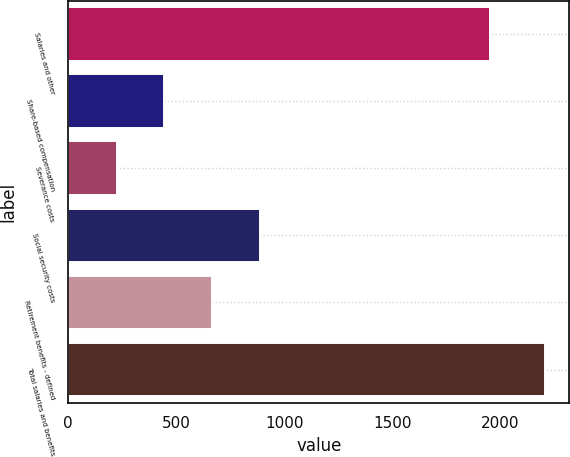<chart> <loc_0><loc_0><loc_500><loc_500><bar_chart><fcel>Salaries and other<fcel>Share-based compensation<fcel>Severance costs<fcel>Social security costs<fcel>Retirement benefits - defined<fcel>Total salaries and benefits<nl><fcel>1953<fcel>444.6<fcel>224.3<fcel>885.2<fcel>664.9<fcel>2207<nl></chart> 